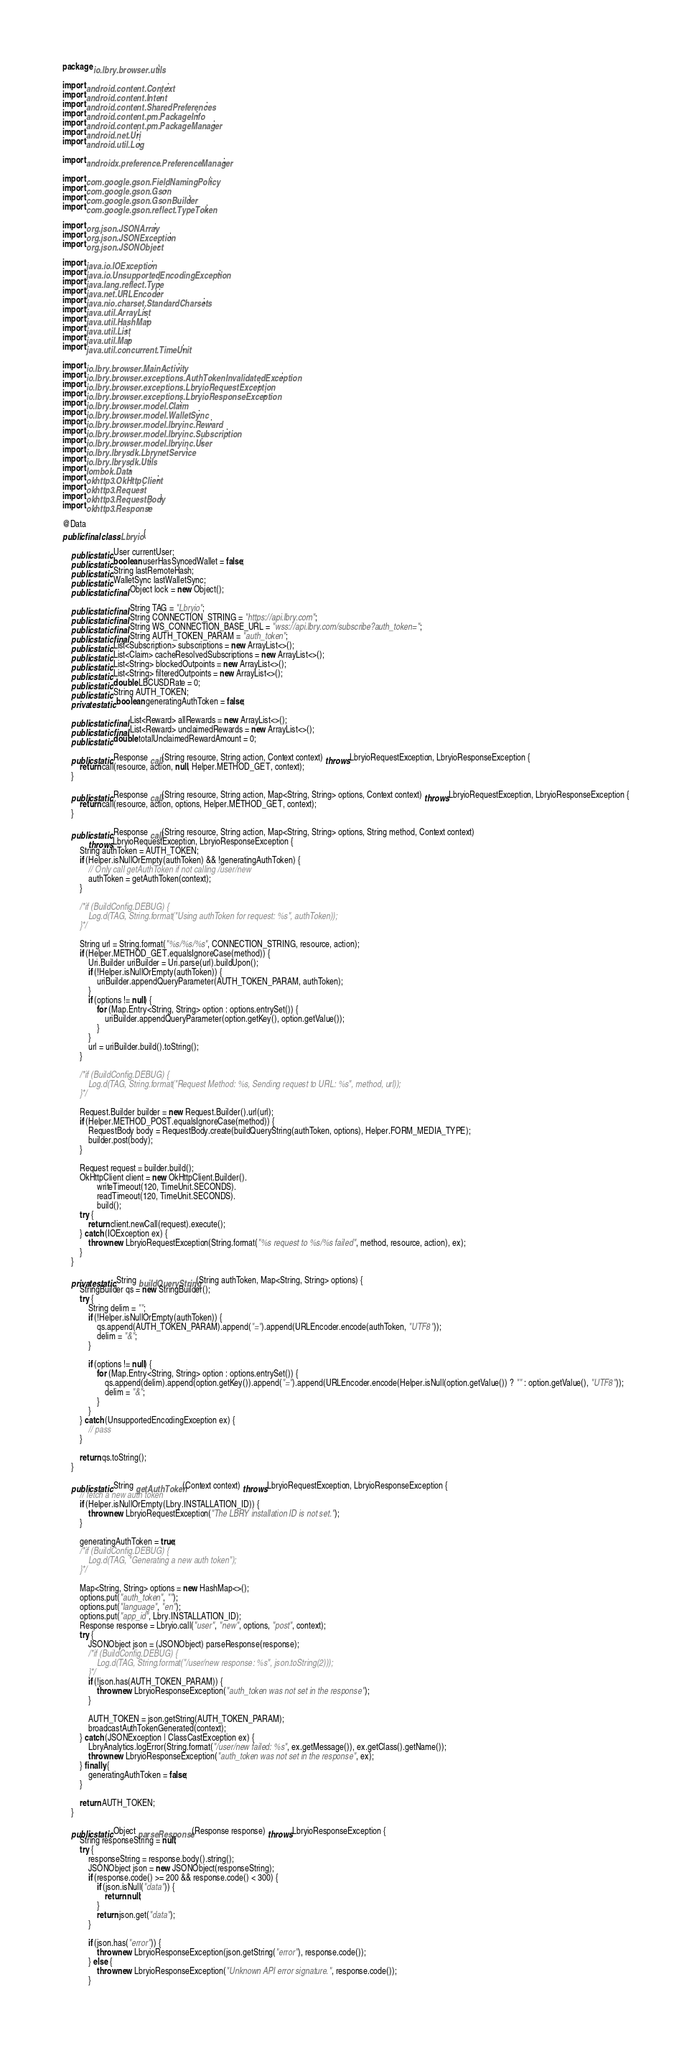Convert code to text. <code><loc_0><loc_0><loc_500><loc_500><_Java_>package io.lbry.browser.utils;

import android.content.Context;
import android.content.Intent;
import android.content.SharedPreferences;
import android.content.pm.PackageInfo;
import android.content.pm.PackageManager;
import android.net.Uri;
import android.util.Log;

import androidx.preference.PreferenceManager;

import com.google.gson.FieldNamingPolicy;
import com.google.gson.Gson;
import com.google.gson.GsonBuilder;
import com.google.gson.reflect.TypeToken;

import org.json.JSONArray;
import org.json.JSONException;
import org.json.JSONObject;

import java.io.IOException;
import java.io.UnsupportedEncodingException;
import java.lang.reflect.Type;
import java.net.URLEncoder;
import java.nio.charset.StandardCharsets;
import java.util.ArrayList;
import java.util.HashMap;
import java.util.List;
import java.util.Map;
import java.util.concurrent.TimeUnit;

import io.lbry.browser.MainActivity;
import io.lbry.browser.exceptions.AuthTokenInvalidatedException;
import io.lbry.browser.exceptions.LbryioRequestException;
import io.lbry.browser.exceptions.LbryioResponseException;
import io.lbry.browser.model.Claim;
import io.lbry.browser.model.WalletSync;
import io.lbry.browser.model.lbryinc.Reward;
import io.lbry.browser.model.lbryinc.Subscription;
import io.lbry.browser.model.lbryinc.User;
import io.lbry.lbrysdk.LbrynetService;
import io.lbry.lbrysdk.Utils;
import lombok.Data;
import okhttp3.OkHttpClient;
import okhttp3.Request;
import okhttp3.RequestBody;
import okhttp3.Response;

@Data
public final class Lbryio {

    public static User currentUser;
    public static boolean userHasSyncedWallet = false;
    public static String lastRemoteHash;
    public static WalletSync lastWalletSync;
    public static final Object lock = new Object();

    public static final String TAG = "Lbryio";
    public static final String CONNECTION_STRING = "https://api.lbry.com";
    public static final String WS_CONNECTION_BASE_URL = "wss://api.lbry.com/subscribe?auth_token=";
    public static final String AUTH_TOKEN_PARAM = "auth_token";
    public static List<Subscription> subscriptions = new ArrayList<>();
    public static List<Claim> cacheResolvedSubscriptions = new ArrayList<>();
    public static List<String> blockedOutpoints = new ArrayList<>();
    public static List<String> filteredOutpoints = new ArrayList<>();
    public static double LBCUSDRate = 0;
    public static String AUTH_TOKEN;
    private static boolean generatingAuthToken = false;

    public static final List<Reward> allRewards = new ArrayList<>();
    public static final List<Reward> unclaimedRewards = new ArrayList<>();
    public static double totalUnclaimedRewardAmount = 0;

    public static Response call(String resource, String action, Context context) throws LbryioRequestException, LbryioResponseException {
        return call(resource, action, null, Helper.METHOD_GET, context);
    }

    public static Response call(String resource, String action, Map<String, String> options, Context context) throws LbryioRequestException, LbryioResponseException {
        return call(resource, action, options, Helper.METHOD_GET, context);
    }

    public static Response call(String resource, String action, Map<String, String> options, String method, Context context)
            throws LbryioRequestException, LbryioResponseException {
        String authToken = AUTH_TOKEN;
        if (Helper.isNullOrEmpty(authToken) && !generatingAuthToken) {
            // Only call getAuthToken if not calling /user/new
            authToken = getAuthToken(context);
        }

        /*if (BuildConfig.DEBUG) {
            Log.d(TAG, String.format("Using authToken for request: %s", authToken));
        }*/

        String url = String.format("%s/%s/%s", CONNECTION_STRING, resource, action);
        if (Helper.METHOD_GET.equalsIgnoreCase(method)) {
            Uri.Builder uriBuilder = Uri.parse(url).buildUpon();
            if (!Helper.isNullOrEmpty(authToken)) {
                uriBuilder.appendQueryParameter(AUTH_TOKEN_PARAM, authToken);
            }
            if (options != null) {
                for (Map.Entry<String, String> option : options.entrySet()) {
                    uriBuilder.appendQueryParameter(option.getKey(), option.getValue());
                }
            }
            url = uriBuilder.build().toString();
        }

        /*if (BuildConfig.DEBUG) {
            Log.d(TAG, String.format("Request Method: %s, Sending request to URL: %s", method, url));
        }*/

        Request.Builder builder = new Request.Builder().url(url);
        if (Helper.METHOD_POST.equalsIgnoreCase(method)) {
            RequestBody body = RequestBody.create(buildQueryString(authToken, options), Helper.FORM_MEDIA_TYPE);
            builder.post(body);
        }

        Request request = builder.build();
        OkHttpClient client = new OkHttpClient.Builder().
                writeTimeout(120, TimeUnit.SECONDS).
                readTimeout(120, TimeUnit.SECONDS).
                build();
        try {
            return client.newCall(request).execute();
        } catch (IOException ex) {
            throw new LbryioRequestException(String.format("%s request to %s/%s failed", method, resource, action), ex);
        }
    }

    private static String buildQueryString(String authToken, Map<String, String> options) {
        StringBuilder qs = new StringBuilder();
        try {
            String delim = "";
            if (!Helper.isNullOrEmpty(authToken)) {
                qs.append(AUTH_TOKEN_PARAM).append("=").append(URLEncoder.encode(authToken, "UTF8"));
                delim = "&";
            }

            if (options != null) {
                for (Map.Entry<String, String> option : options.entrySet()) {
                    qs.append(delim).append(option.getKey()).append("=").append(URLEncoder.encode(Helper.isNull(option.getValue()) ? "" : option.getValue(), "UTF8"));
                    delim = "&";
                }
            }
        } catch (UnsupportedEncodingException ex) {
            // pass
        }

        return qs.toString();
    }

    public static String getAuthToken(Context context) throws LbryioRequestException, LbryioResponseException {
        // fetch a new auth token
        if (Helper.isNullOrEmpty(Lbry.INSTALLATION_ID)) {
            throw new LbryioRequestException("The LBRY installation ID is not set.");
        }

        generatingAuthToken = true;
        /*if (BuildConfig.DEBUG) {
            Log.d(TAG, "Generating a new auth token");
        }*/

        Map<String, String> options = new HashMap<>();
        options.put("auth_token", "");
        options.put("language", "en");
        options.put("app_id", Lbry.INSTALLATION_ID);
        Response response = Lbryio.call("user", "new", options, "post", context);
        try {
            JSONObject json = (JSONObject) parseResponse(response);
            /*if (BuildConfig.DEBUG) {
                Log.d(TAG, String.format("/user/new response: %s", json.toString(2)));
            }*/
            if (!json.has(AUTH_TOKEN_PARAM)) {
                throw new LbryioResponseException("auth_token was not set in the response");
            }

            AUTH_TOKEN = json.getString(AUTH_TOKEN_PARAM);
            broadcastAuthTokenGenerated(context);
        } catch (JSONException | ClassCastException ex) {
            LbryAnalytics.logError(String.format("/user/new failed: %s", ex.getMessage()), ex.getClass().getName());
            throw new LbryioResponseException("auth_token was not set in the response", ex);
        } finally {
            generatingAuthToken = false;
        }

        return AUTH_TOKEN;
    }

    public static Object parseResponse(Response response) throws LbryioResponseException {
        String responseString = null;
        try {
            responseString = response.body().string();
            JSONObject json = new JSONObject(responseString);
            if (response.code() >= 200 && response.code() < 300) {
                if (json.isNull("data")) {
                    return null;
                }
                return json.get("data");
            }

            if (json.has("error")) {
                throw new LbryioResponseException(json.getString("error"), response.code());
            } else {
                throw new LbryioResponseException("Unknown API error signature.", response.code());
            }</code> 